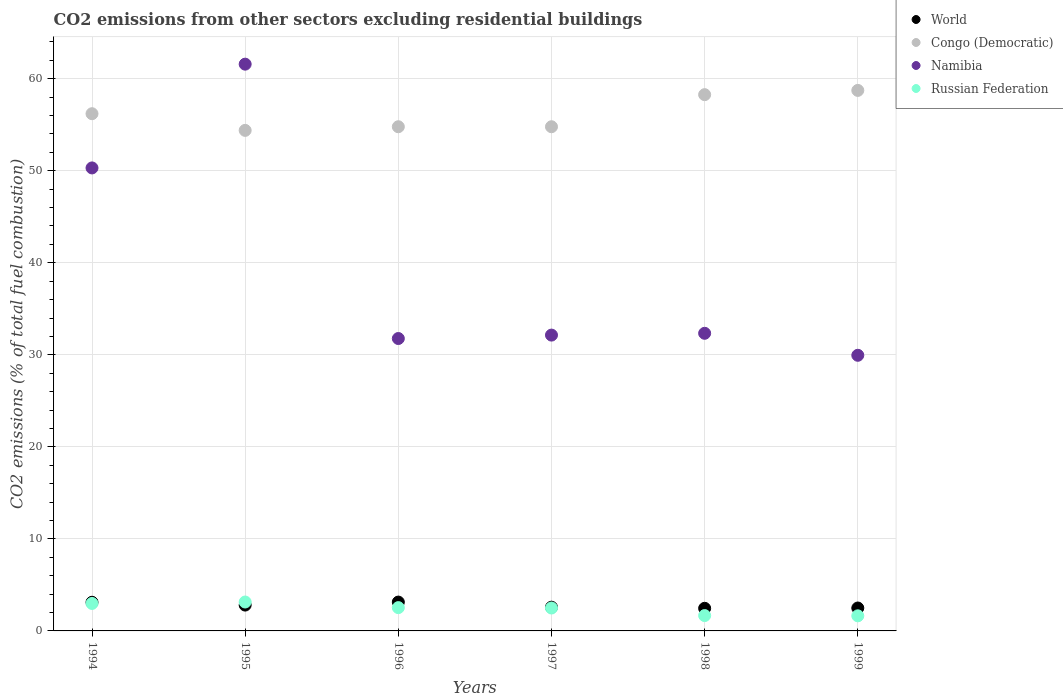How many different coloured dotlines are there?
Keep it short and to the point. 4. What is the total CO2 emitted in World in 1999?
Provide a short and direct response. 2.49. Across all years, what is the maximum total CO2 emitted in Namibia?
Ensure brevity in your answer.  61.58. Across all years, what is the minimum total CO2 emitted in World?
Your answer should be very brief. 2.46. What is the total total CO2 emitted in Congo (Democratic) in the graph?
Keep it short and to the point. 337.15. What is the difference between the total CO2 emitted in Congo (Democratic) in 1994 and that in 1998?
Keep it short and to the point. -2.07. What is the difference between the total CO2 emitted in Russian Federation in 1994 and the total CO2 emitted in World in 1995?
Your answer should be compact. 0.18. What is the average total CO2 emitted in Congo (Democratic) per year?
Offer a very short reply. 56.19. In the year 1996, what is the difference between the total CO2 emitted in World and total CO2 emitted in Namibia?
Your response must be concise. -28.64. What is the ratio of the total CO2 emitted in Congo (Democratic) in 1994 to that in 1997?
Offer a terse response. 1.03. What is the difference between the highest and the second highest total CO2 emitted in Russian Federation?
Provide a short and direct response. 0.16. What is the difference between the highest and the lowest total CO2 emitted in World?
Your response must be concise. 0.68. Is it the case that in every year, the sum of the total CO2 emitted in Congo (Democratic) and total CO2 emitted in Russian Federation  is greater than the total CO2 emitted in Namibia?
Offer a very short reply. No. Does the total CO2 emitted in World monotonically increase over the years?
Ensure brevity in your answer.  No. Is the total CO2 emitted in World strictly greater than the total CO2 emitted in Congo (Democratic) over the years?
Your answer should be compact. No. Is the total CO2 emitted in Namibia strictly less than the total CO2 emitted in Russian Federation over the years?
Offer a terse response. No. How many dotlines are there?
Keep it short and to the point. 4. How many years are there in the graph?
Your response must be concise. 6. What is the difference between two consecutive major ticks on the Y-axis?
Your answer should be compact. 10. Are the values on the major ticks of Y-axis written in scientific E-notation?
Make the answer very short. No. Does the graph contain any zero values?
Make the answer very short. No. Does the graph contain grids?
Offer a very short reply. Yes. How many legend labels are there?
Offer a terse response. 4. How are the legend labels stacked?
Offer a terse response. Vertical. What is the title of the graph?
Ensure brevity in your answer.  CO2 emissions from other sectors excluding residential buildings. Does "Latin America(all income levels)" appear as one of the legend labels in the graph?
Your response must be concise. No. What is the label or title of the X-axis?
Keep it short and to the point. Years. What is the label or title of the Y-axis?
Offer a very short reply. CO2 emissions (% of total fuel combustion). What is the CO2 emissions (% of total fuel combustion) of World in 1994?
Make the answer very short. 3.11. What is the CO2 emissions (% of total fuel combustion) in Congo (Democratic) in 1994?
Offer a terse response. 56.2. What is the CO2 emissions (% of total fuel combustion) of Namibia in 1994?
Provide a succinct answer. 50.31. What is the CO2 emissions (% of total fuel combustion) in Russian Federation in 1994?
Make the answer very short. 2.99. What is the CO2 emissions (% of total fuel combustion) of World in 1995?
Provide a short and direct response. 2.81. What is the CO2 emissions (% of total fuel combustion) in Congo (Democratic) in 1995?
Keep it short and to the point. 54.39. What is the CO2 emissions (% of total fuel combustion) in Namibia in 1995?
Provide a short and direct response. 61.58. What is the CO2 emissions (% of total fuel combustion) of Russian Federation in 1995?
Make the answer very short. 3.14. What is the CO2 emissions (% of total fuel combustion) in World in 1996?
Provide a short and direct response. 3.13. What is the CO2 emissions (% of total fuel combustion) in Congo (Democratic) in 1996?
Provide a succinct answer. 54.78. What is the CO2 emissions (% of total fuel combustion) in Namibia in 1996?
Ensure brevity in your answer.  31.77. What is the CO2 emissions (% of total fuel combustion) of Russian Federation in 1996?
Ensure brevity in your answer.  2.53. What is the CO2 emissions (% of total fuel combustion) of World in 1997?
Ensure brevity in your answer.  2.58. What is the CO2 emissions (% of total fuel combustion) of Congo (Democratic) in 1997?
Your answer should be compact. 54.78. What is the CO2 emissions (% of total fuel combustion) in Namibia in 1997?
Ensure brevity in your answer.  32.14. What is the CO2 emissions (% of total fuel combustion) in Russian Federation in 1997?
Your response must be concise. 2.49. What is the CO2 emissions (% of total fuel combustion) of World in 1998?
Ensure brevity in your answer.  2.46. What is the CO2 emissions (% of total fuel combustion) in Congo (Democratic) in 1998?
Make the answer very short. 58.27. What is the CO2 emissions (% of total fuel combustion) of Namibia in 1998?
Ensure brevity in your answer.  32.34. What is the CO2 emissions (% of total fuel combustion) in Russian Federation in 1998?
Keep it short and to the point. 1.67. What is the CO2 emissions (% of total fuel combustion) of World in 1999?
Your response must be concise. 2.49. What is the CO2 emissions (% of total fuel combustion) in Congo (Democratic) in 1999?
Offer a very short reply. 58.73. What is the CO2 emissions (% of total fuel combustion) of Namibia in 1999?
Your answer should be very brief. 29.95. What is the CO2 emissions (% of total fuel combustion) in Russian Federation in 1999?
Provide a short and direct response. 1.64. Across all years, what is the maximum CO2 emissions (% of total fuel combustion) of World?
Your answer should be compact. 3.13. Across all years, what is the maximum CO2 emissions (% of total fuel combustion) of Congo (Democratic)?
Your answer should be very brief. 58.73. Across all years, what is the maximum CO2 emissions (% of total fuel combustion) of Namibia?
Give a very brief answer. 61.58. Across all years, what is the maximum CO2 emissions (% of total fuel combustion) in Russian Federation?
Your response must be concise. 3.14. Across all years, what is the minimum CO2 emissions (% of total fuel combustion) in World?
Your response must be concise. 2.46. Across all years, what is the minimum CO2 emissions (% of total fuel combustion) in Congo (Democratic)?
Provide a short and direct response. 54.39. Across all years, what is the minimum CO2 emissions (% of total fuel combustion) in Namibia?
Provide a short and direct response. 29.95. Across all years, what is the minimum CO2 emissions (% of total fuel combustion) in Russian Federation?
Your answer should be very brief. 1.64. What is the total CO2 emissions (% of total fuel combustion) in World in the graph?
Make the answer very short. 16.58. What is the total CO2 emissions (% of total fuel combustion) of Congo (Democratic) in the graph?
Keep it short and to the point. 337.15. What is the total CO2 emissions (% of total fuel combustion) of Namibia in the graph?
Keep it short and to the point. 238.09. What is the total CO2 emissions (% of total fuel combustion) of Russian Federation in the graph?
Offer a terse response. 14.46. What is the difference between the CO2 emissions (% of total fuel combustion) in World in 1994 and that in 1995?
Make the answer very short. 0.3. What is the difference between the CO2 emissions (% of total fuel combustion) of Congo (Democratic) in 1994 and that in 1995?
Provide a short and direct response. 1.81. What is the difference between the CO2 emissions (% of total fuel combustion) of Namibia in 1994 and that in 1995?
Provide a succinct answer. -11.28. What is the difference between the CO2 emissions (% of total fuel combustion) in Russian Federation in 1994 and that in 1995?
Give a very brief answer. -0.16. What is the difference between the CO2 emissions (% of total fuel combustion) in World in 1994 and that in 1996?
Provide a short and direct response. -0.02. What is the difference between the CO2 emissions (% of total fuel combustion) in Congo (Democratic) in 1994 and that in 1996?
Offer a very short reply. 1.42. What is the difference between the CO2 emissions (% of total fuel combustion) of Namibia in 1994 and that in 1996?
Your answer should be compact. 18.54. What is the difference between the CO2 emissions (% of total fuel combustion) of Russian Federation in 1994 and that in 1996?
Give a very brief answer. 0.45. What is the difference between the CO2 emissions (% of total fuel combustion) in World in 1994 and that in 1997?
Offer a very short reply. 0.53. What is the difference between the CO2 emissions (% of total fuel combustion) in Congo (Democratic) in 1994 and that in 1997?
Keep it short and to the point. 1.42. What is the difference between the CO2 emissions (% of total fuel combustion) of Namibia in 1994 and that in 1997?
Your answer should be very brief. 18.16. What is the difference between the CO2 emissions (% of total fuel combustion) in Russian Federation in 1994 and that in 1997?
Offer a terse response. 0.5. What is the difference between the CO2 emissions (% of total fuel combustion) of World in 1994 and that in 1998?
Your response must be concise. 0.66. What is the difference between the CO2 emissions (% of total fuel combustion) of Congo (Democratic) in 1994 and that in 1998?
Ensure brevity in your answer.  -2.07. What is the difference between the CO2 emissions (% of total fuel combustion) of Namibia in 1994 and that in 1998?
Your answer should be compact. 17.97. What is the difference between the CO2 emissions (% of total fuel combustion) of Russian Federation in 1994 and that in 1998?
Make the answer very short. 1.32. What is the difference between the CO2 emissions (% of total fuel combustion) in World in 1994 and that in 1999?
Ensure brevity in your answer.  0.62. What is the difference between the CO2 emissions (% of total fuel combustion) in Congo (Democratic) in 1994 and that in 1999?
Give a very brief answer. -2.53. What is the difference between the CO2 emissions (% of total fuel combustion) in Namibia in 1994 and that in 1999?
Ensure brevity in your answer.  20.36. What is the difference between the CO2 emissions (% of total fuel combustion) in Russian Federation in 1994 and that in 1999?
Keep it short and to the point. 1.34. What is the difference between the CO2 emissions (% of total fuel combustion) in World in 1995 and that in 1996?
Your answer should be very brief. -0.33. What is the difference between the CO2 emissions (% of total fuel combustion) in Congo (Democratic) in 1995 and that in 1996?
Keep it short and to the point. -0.4. What is the difference between the CO2 emissions (% of total fuel combustion) in Namibia in 1995 and that in 1996?
Your response must be concise. 29.81. What is the difference between the CO2 emissions (% of total fuel combustion) of Russian Federation in 1995 and that in 1996?
Ensure brevity in your answer.  0.61. What is the difference between the CO2 emissions (% of total fuel combustion) in World in 1995 and that in 1997?
Your response must be concise. 0.23. What is the difference between the CO2 emissions (% of total fuel combustion) of Congo (Democratic) in 1995 and that in 1997?
Provide a short and direct response. -0.4. What is the difference between the CO2 emissions (% of total fuel combustion) in Namibia in 1995 and that in 1997?
Your answer should be very brief. 29.44. What is the difference between the CO2 emissions (% of total fuel combustion) in Russian Federation in 1995 and that in 1997?
Offer a terse response. 0.65. What is the difference between the CO2 emissions (% of total fuel combustion) of World in 1995 and that in 1998?
Keep it short and to the point. 0.35. What is the difference between the CO2 emissions (% of total fuel combustion) of Congo (Democratic) in 1995 and that in 1998?
Your response must be concise. -3.88. What is the difference between the CO2 emissions (% of total fuel combustion) in Namibia in 1995 and that in 1998?
Ensure brevity in your answer.  29.24. What is the difference between the CO2 emissions (% of total fuel combustion) in Russian Federation in 1995 and that in 1998?
Your answer should be very brief. 1.47. What is the difference between the CO2 emissions (% of total fuel combustion) in World in 1995 and that in 1999?
Provide a short and direct response. 0.32. What is the difference between the CO2 emissions (% of total fuel combustion) of Congo (Democratic) in 1995 and that in 1999?
Offer a terse response. -4.34. What is the difference between the CO2 emissions (% of total fuel combustion) of Namibia in 1995 and that in 1999?
Ensure brevity in your answer.  31.63. What is the difference between the CO2 emissions (% of total fuel combustion) of Russian Federation in 1995 and that in 1999?
Your answer should be compact. 1.5. What is the difference between the CO2 emissions (% of total fuel combustion) in World in 1996 and that in 1997?
Give a very brief answer. 0.56. What is the difference between the CO2 emissions (% of total fuel combustion) of Namibia in 1996 and that in 1997?
Your answer should be compact. -0.37. What is the difference between the CO2 emissions (% of total fuel combustion) of Russian Federation in 1996 and that in 1997?
Keep it short and to the point. 0.04. What is the difference between the CO2 emissions (% of total fuel combustion) of World in 1996 and that in 1998?
Offer a very short reply. 0.68. What is the difference between the CO2 emissions (% of total fuel combustion) in Congo (Democratic) in 1996 and that in 1998?
Provide a short and direct response. -3.49. What is the difference between the CO2 emissions (% of total fuel combustion) of Namibia in 1996 and that in 1998?
Your answer should be very brief. -0.57. What is the difference between the CO2 emissions (% of total fuel combustion) in Russian Federation in 1996 and that in 1998?
Offer a terse response. 0.86. What is the difference between the CO2 emissions (% of total fuel combustion) of World in 1996 and that in 1999?
Your response must be concise. 0.64. What is the difference between the CO2 emissions (% of total fuel combustion) in Congo (Democratic) in 1996 and that in 1999?
Keep it short and to the point. -3.95. What is the difference between the CO2 emissions (% of total fuel combustion) of Namibia in 1996 and that in 1999?
Give a very brief answer. 1.82. What is the difference between the CO2 emissions (% of total fuel combustion) of Russian Federation in 1996 and that in 1999?
Provide a short and direct response. 0.89. What is the difference between the CO2 emissions (% of total fuel combustion) of World in 1997 and that in 1998?
Keep it short and to the point. 0.12. What is the difference between the CO2 emissions (% of total fuel combustion) of Congo (Democratic) in 1997 and that in 1998?
Offer a terse response. -3.49. What is the difference between the CO2 emissions (% of total fuel combustion) in Namibia in 1997 and that in 1998?
Your answer should be compact. -0.2. What is the difference between the CO2 emissions (% of total fuel combustion) of Russian Federation in 1997 and that in 1998?
Give a very brief answer. 0.82. What is the difference between the CO2 emissions (% of total fuel combustion) of World in 1997 and that in 1999?
Ensure brevity in your answer.  0.09. What is the difference between the CO2 emissions (% of total fuel combustion) of Congo (Democratic) in 1997 and that in 1999?
Give a very brief answer. -3.95. What is the difference between the CO2 emissions (% of total fuel combustion) of Namibia in 1997 and that in 1999?
Provide a short and direct response. 2.19. What is the difference between the CO2 emissions (% of total fuel combustion) in Russian Federation in 1997 and that in 1999?
Your answer should be compact. 0.85. What is the difference between the CO2 emissions (% of total fuel combustion) in World in 1998 and that in 1999?
Provide a short and direct response. -0.03. What is the difference between the CO2 emissions (% of total fuel combustion) in Congo (Democratic) in 1998 and that in 1999?
Provide a succinct answer. -0.46. What is the difference between the CO2 emissions (% of total fuel combustion) of Namibia in 1998 and that in 1999?
Offer a terse response. 2.39. What is the difference between the CO2 emissions (% of total fuel combustion) in Russian Federation in 1998 and that in 1999?
Make the answer very short. 0.03. What is the difference between the CO2 emissions (% of total fuel combustion) in World in 1994 and the CO2 emissions (% of total fuel combustion) in Congo (Democratic) in 1995?
Keep it short and to the point. -51.27. What is the difference between the CO2 emissions (% of total fuel combustion) in World in 1994 and the CO2 emissions (% of total fuel combustion) in Namibia in 1995?
Your answer should be very brief. -58.47. What is the difference between the CO2 emissions (% of total fuel combustion) in World in 1994 and the CO2 emissions (% of total fuel combustion) in Russian Federation in 1995?
Make the answer very short. -0.03. What is the difference between the CO2 emissions (% of total fuel combustion) of Congo (Democratic) in 1994 and the CO2 emissions (% of total fuel combustion) of Namibia in 1995?
Make the answer very short. -5.38. What is the difference between the CO2 emissions (% of total fuel combustion) of Congo (Democratic) in 1994 and the CO2 emissions (% of total fuel combustion) of Russian Federation in 1995?
Your answer should be compact. 53.06. What is the difference between the CO2 emissions (% of total fuel combustion) in Namibia in 1994 and the CO2 emissions (% of total fuel combustion) in Russian Federation in 1995?
Give a very brief answer. 47.17. What is the difference between the CO2 emissions (% of total fuel combustion) of World in 1994 and the CO2 emissions (% of total fuel combustion) of Congo (Democratic) in 1996?
Your answer should be very brief. -51.67. What is the difference between the CO2 emissions (% of total fuel combustion) of World in 1994 and the CO2 emissions (% of total fuel combustion) of Namibia in 1996?
Make the answer very short. -28.66. What is the difference between the CO2 emissions (% of total fuel combustion) of World in 1994 and the CO2 emissions (% of total fuel combustion) of Russian Federation in 1996?
Offer a very short reply. 0.58. What is the difference between the CO2 emissions (% of total fuel combustion) in Congo (Democratic) in 1994 and the CO2 emissions (% of total fuel combustion) in Namibia in 1996?
Provide a short and direct response. 24.43. What is the difference between the CO2 emissions (% of total fuel combustion) in Congo (Democratic) in 1994 and the CO2 emissions (% of total fuel combustion) in Russian Federation in 1996?
Give a very brief answer. 53.67. What is the difference between the CO2 emissions (% of total fuel combustion) of Namibia in 1994 and the CO2 emissions (% of total fuel combustion) of Russian Federation in 1996?
Provide a short and direct response. 47.78. What is the difference between the CO2 emissions (% of total fuel combustion) in World in 1994 and the CO2 emissions (% of total fuel combustion) in Congo (Democratic) in 1997?
Offer a very short reply. -51.67. What is the difference between the CO2 emissions (% of total fuel combustion) of World in 1994 and the CO2 emissions (% of total fuel combustion) of Namibia in 1997?
Offer a terse response. -29.03. What is the difference between the CO2 emissions (% of total fuel combustion) of World in 1994 and the CO2 emissions (% of total fuel combustion) of Russian Federation in 1997?
Provide a succinct answer. 0.62. What is the difference between the CO2 emissions (% of total fuel combustion) of Congo (Democratic) in 1994 and the CO2 emissions (% of total fuel combustion) of Namibia in 1997?
Your answer should be very brief. 24.06. What is the difference between the CO2 emissions (% of total fuel combustion) in Congo (Democratic) in 1994 and the CO2 emissions (% of total fuel combustion) in Russian Federation in 1997?
Offer a terse response. 53.71. What is the difference between the CO2 emissions (% of total fuel combustion) of Namibia in 1994 and the CO2 emissions (% of total fuel combustion) of Russian Federation in 1997?
Your answer should be compact. 47.82. What is the difference between the CO2 emissions (% of total fuel combustion) in World in 1994 and the CO2 emissions (% of total fuel combustion) in Congo (Democratic) in 1998?
Give a very brief answer. -55.16. What is the difference between the CO2 emissions (% of total fuel combustion) of World in 1994 and the CO2 emissions (% of total fuel combustion) of Namibia in 1998?
Offer a terse response. -29.23. What is the difference between the CO2 emissions (% of total fuel combustion) of World in 1994 and the CO2 emissions (% of total fuel combustion) of Russian Federation in 1998?
Your response must be concise. 1.44. What is the difference between the CO2 emissions (% of total fuel combustion) in Congo (Democratic) in 1994 and the CO2 emissions (% of total fuel combustion) in Namibia in 1998?
Offer a terse response. 23.86. What is the difference between the CO2 emissions (% of total fuel combustion) in Congo (Democratic) in 1994 and the CO2 emissions (% of total fuel combustion) in Russian Federation in 1998?
Offer a terse response. 54.53. What is the difference between the CO2 emissions (% of total fuel combustion) in Namibia in 1994 and the CO2 emissions (% of total fuel combustion) in Russian Federation in 1998?
Offer a terse response. 48.64. What is the difference between the CO2 emissions (% of total fuel combustion) of World in 1994 and the CO2 emissions (% of total fuel combustion) of Congo (Democratic) in 1999?
Provide a short and direct response. -55.62. What is the difference between the CO2 emissions (% of total fuel combustion) of World in 1994 and the CO2 emissions (% of total fuel combustion) of Namibia in 1999?
Provide a short and direct response. -26.84. What is the difference between the CO2 emissions (% of total fuel combustion) in World in 1994 and the CO2 emissions (% of total fuel combustion) in Russian Federation in 1999?
Offer a very short reply. 1.47. What is the difference between the CO2 emissions (% of total fuel combustion) in Congo (Democratic) in 1994 and the CO2 emissions (% of total fuel combustion) in Namibia in 1999?
Give a very brief answer. 26.25. What is the difference between the CO2 emissions (% of total fuel combustion) in Congo (Democratic) in 1994 and the CO2 emissions (% of total fuel combustion) in Russian Federation in 1999?
Your response must be concise. 54.56. What is the difference between the CO2 emissions (% of total fuel combustion) in Namibia in 1994 and the CO2 emissions (% of total fuel combustion) in Russian Federation in 1999?
Provide a short and direct response. 48.67. What is the difference between the CO2 emissions (% of total fuel combustion) in World in 1995 and the CO2 emissions (% of total fuel combustion) in Congo (Democratic) in 1996?
Provide a succinct answer. -51.97. What is the difference between the CO2 emissions (% of total fuel combustion) of World in 1995 and the CO2 emissions (% of total fuel combustion) of Namibia in 1996?
Your answer should be very brief. -28.96. What is the difference between the CO2 emissions (% of total fuel combustion) of World in 1995 and the CO2 emissions (% of total fuel combustion) of Russian Federation in 1996?
Ensure brevity in your answer.  0.28. What is the difference between the CO2 emissions (% of total fuel combustion) in Congo (Democratic) in 1995 and the CO2 emissions (% of total fuel combustion) in Namibia in 1996?
Your response must be concise. 22.62. What is the difference between the CO2 emissions (% of total fuel combustion) of Congo (Democratic) in 1995 and the CO2 emissions (% of total fuel combustion) of Russian Federation in 1996?
Your answer should be very brief. 51.85. What is the difference between the CO2 emissions (% of total fuel combustion) in Namibia in 1995 and the CO2 emissions (% of total fuel combustion) in Russian Federation in 1996?
Your response must be concise. 59.05. What is the difference between the CO2 emissions (% of total fuel combustion) in World in 1995 and the CO2 emissions (% of total fuel combustion) in Congo (Democratic) in 1997?
Offer a very short reply. -51.97. What is the difference between the CO2 emissions (% of total fuel combustion) of World in 1995 and the CO2 emissions (% of total fuel combustion) of Namibia in 1997?
Give a very brief answer. -29.34. What is the difference between the CO2 emissions (% of total fuel combustion) of World in 1995 and the CO2 emissions (% of total fuel combustion) of Russian Federation in 1997?
Provide a short and direct response. 0.32. What is the difference between the CO2 emissions (% of total fuel combustion) of Congo (Democratic) in 1995 and the CO2 emissions (% of total fuel combustion) of Namibia in 1997?
Offer a very short reply. 22.24. What is the difference between the CO2 emissions (% of total fuel combustion) in Congo (Democratic) in 1995 and the CO2 emissions (% of total fuel combustion) in Russian Federation in 1997?
Your answer should be very brief. 51.9. What is the difference between the CO2 emissions (% of total fuel combustion) of Namibia in 1995 and the CO2 emissions (% of total fuel combustion) of Russian Federation in 1997?
Offer a terse response. 59.09. What is the difference between the CO2 emissions (% of total fuel combustion) of World in 1995 and the CO2 emissions (% of total fuel combustion) of Congo (Democratic) in 1998?
Ensure brevity in your answer.  -55.46. What is the difference between the CO2 emissions (% of total fuel combustion) in World in 1995 and the CO2 emissions (% of total fuel combustion) in Namibia in 1998?
Your response must be concise. -29.53. What is the difference between the CO2 emissions (% of total fuel combustion) of World in 1995 and the CO2 emissions (% of total fuel combustion) of Russian Federation in 1998?
Offer a very short reply. 1.14. What is the difference between the CO2 emissions (% of total fuel combustion) of Congo (Democratic) in 1995 and the CO2 emissions (% of total fuel combustion) of Namibia in 1998?
Keep it short and to the point. 22.05. What is the difference between the CO2 emissions (% of total fuel combustion) of Congo (Democratic) in 1995 and the CO2 emissions (% of total fuel combustion) of Russian Federation in 1998?
Your answer should be compact. 52.72. What is the difference between the CO2 emissions (% of total fuel combustion) of Namibia in 1995 and the CO2 emissions (% of total fuel combustion) of Russian Federation in 1998?
Make the answer very short. 59.91. What is the difference between the CO2 emissions (% of total fuel combustion) in World in 1995 and the CO2 emissions (% of total fuel combustion) in Congo (Democratic) in 1999?
Your response must be concise. -55.92. What is the difference between the CO2 emissions (% of total fuel combustion) of World in 1995 and the CO2 emissions (% of total fuel combustion) of Namibia in 1999?
Ensure brevity in your answer.  -27.14. What is the difference between the CO2 emissions (% of total fuel combustion) of World in 1995 and the CO2 emissions (% of total fuel combustion) of Russian Federation in 1999?
Offer a terse response. 1.17. What is the difference between the CO2 emissions (% of total fuel combustion) of Congo (Democratic) in 1995 and the CO2 emissions (% of total fuel combustion) of Namibia in 1999?
Provide a short and direct response. 24.44. What is the difference between the CO2 emissions (% of total fuel combustion) in Congo (Democratic) in 1995 and the CO2 emissions (% of total fuel combustion) in Russian Federation in 1999?
Provide a succinct answer. 52.74. What is the difference between the CO2 emissions (% of total fuel combustion) in Namibia in 1995 and the CO2 emissions (% of total fuel combustion) in Russian Federation in 1999?
Give a very brief answer. 59.94. What is the difference between the CO2 emissions (% of total fuel combustion) in World in 1996 and the CO2 emissions (% of total fuel combustion) in Congo (Democratic) in 1997?
Offer a terse response. -51.65. What is the difference between the CO2 emissions (% of total fuel combustion) of World in 1996 and the CO2 emissions (% of total fuel combustion) of Namibia in 1997?
Give a very brief answer. -29.01. What is the difference between the CO2 emissions (% of total fuel combustion) in World in 1996 and the CO2 emissions (% of total fuel combustion) in Russian Federation in 1997?
Your answer should be compact. 0.64. What is the difference between the CO2 emissions (% of total fuel combustion) of Congo (Democratic) in 1996 and the CO2 emissions (% of total fuel combustion) of Namibia in 1997?
Your answer should be compact. 22.64. What is the difference between the CO2 emissions (% of total fuel combustion) in Congo (Democratic) in 1996 and the CO2 emissions (% of total fuel combustion) in Russian Federation in 1997?
Offer a very short reply. 52.29. What is the difference between the CO2 emissions (% of total fuel combustion) of Namibia in 1996 and the CO2 emissions (% of total fuel combustion) of Russian Federation in 1997?
Offer a terse response. 29.28. What is the difference between the CO2 emissions (% of total fuel combustion) of World in 1996 and the CO2 emissions (% of total fuel combustion) of Congo (Democratic) in 1998?
Provide a succinct answer. -55.13. What is the difference between the CO2 emissions (% of total fuel combustion) in World in 1996 and the CO2 emissions (% of total fuel combustion) in Namibia in 1998?
Ensure brevity in your answer.  -29.2. What is the difference between the CO2 emissions (% of total fuel combustion) of World in 1996 and the CO2 emissions (% of total fuel combustion) of Russian Federation in 1998?
Your response must be concise. 1.47. What is the difference between the CO2 emissions (% of total fuel combustion) of Congo (Democratic) in 1996 and the CO2 emissions (% of total fuel combustion) of Namibia in 1998?
Give a very brief answer. 22.44. What is the difference between the CO2 emissions (% of total fuel combustion) in Congo (Democratic) in 1996 and the CO2 emissions (% of total fuel combustion) in Russian Federation in 1998?
Your answer should be compact. 53.12. What is the difference between the CO2 emissions (% of total fuel combustion) of Namibia in 1996 and the CO2 emissions (% of total fuel combustion) of Russian Federation in 1998?
Provide a succinct answer. 30.1. What is the difference between the CO2 emissions (% of total fuel combustion) in World in 1996 and the CO2 emissions (% of total fuel combustion) in Congo (Democratic) in 1999?
Offer a very short reply. -55.6. What is the difference between the CO2 emissions (% of total fuel combustion) in World in 1996 and the CO2 emissions (% of total fuel combustion) in Namibia in 1999?
Ensure brevity in your answer.  -26.82. What is the difference between the CO2 emissions (% of total fuel combustion) in World in 1996 and the CO2 emissions (% of total fuel combustion) in Russian Federation in 1999?
Your response must be concise. 1.49. What is the difference between the CO2 emissions (% of total fuel combustion) of Congo (Democratic) in 1996 and the CO2 emissions (% of total fuel combustion) of Namibia in 1999?
Your response must be concise. 24.83. What is the difference between the CO2 emissions (% of total fuel combustion) in Congo (Democratic) in 1996 and the CO2 emissions (% of total fuel combustion) in Russian Federation in 1999?
Keep it short and to the point. 53.14. What is the difference between the CO2 emissions (% of total fuel combustion) of Namibia in 1996 and the CO2 emissions (% of total fuel combustion) of Russian Federation in 1999?
Offer a terse response. 30.13. What is the difference between the CO2 emissions (% of total fuel combustion) in World in 1997 and the CO2 emissions (% of total fuel combustion) in Congo (Democratic) in 1998?
Provide a short and direct response. -55.69. What is the difference between the CO2 emissions (% of total fuel combustion) of World in 1997 and the CO2 emissions (% of total fuel combustion) of Namibia in 1998?
Make the answer very short. -29.76. What is the difference between the CO2 emissions (% of total fuel combustion) in World in 1997 and the CO2 emissions (% of total fuel combustion) in Russian Federation in 1998?
Your answer should be compact. 0.91. What is the difference between the CO2 emissions (% of total fuel combustion) in Congo (Democratic) in 1997 and the CO2 emissions (% of total fuel combustion) in Namibia in 1998?
Your answer should be very brief. 22.44. What is the difference between the CO2 emissions (% of total fuel combustion) in Congo (Democratic) in 1997 and the CO2 emissions (% of total fuel combustion) in Russian Federation in 1998?
Your answer should be very brief. 53.12. What is the difference between the CO2 emissions (% of total fuel combustion) of Namibia in 1997 and the CO2 emissions (% of total fuel combustion) of Russian Federation in 1998?
Keep it short and to the point. 30.48. What is the difference between the CO2 emissions (% of total fuel combustion) in World in 1997 and the CO2 emissions (% of total fuel combustion) in Congo (Democratic) in 1999?
Provide a short and direct response. -56.15. What is the difference between the CO2 emissions (% of total fuel combustion) in World in 1997 and the CO2 emissions (% of total fuel combustion) in Namibia in 1999?
Offer a very short reply. -27.37. What is the difference between the CO2 emissions (% of total fuel combustion) in World in 1997 and the CO2 emissions (% of total fuel combustion) in Russian Federation in 1999?
Keep it short and to the point. 0.94. What is the difference between the CO2 emissions (% of total fuel combustion) of Congo (Democratic) in 1997 and the CO2 emissions (% of total fuel combustion) of Namibia in 1999?
Provide a succinct answer. 24.83. What is the difference between the CO2 emissions (% of total fuel combustion) of Congo (Democratic) in 1997 and the CO2 emissions (% of total fuel combustion) of Russian Federation in 1999?
Your response must be concise. 53.14. What is the difference between the CO2 emissions (% of total fuel combustion) in Namibia in 1997 and the CO2 emissions (% of total fuel combustion) in Russian Federation in 1999?
Your answer should be very brief. 30.5. What is the difference between the CO2 emissions (% of total fuel combustion) of World in 1998 and the CO2 emissions (% of total fuel combustion) of Congo (Democratic) in 1999?
Make the answer very short. -56.27. What is the difference between the CO2 emissions (% of total fuel combustion) of World in 1998 and the CO2 emissions (% of total fuel combustion) of Namibia in 1999?
Your response must be concise. -27.49. What is the difference between the CO2 emissions (% of total fuel combustion) in World in 1998 and the CO2 emissions (% of total fuel combustion) in Russian Federation in 1999?
Your response must be concise. 0.82. What is the difference between the CO2 emissions (% of total fuel combustion) in Congo (Democratic) in 1998 and the CO2 emissions (% of total fuel combustion) in Namibia in 1999?
Give a very brief answer. 28.32. What is the difference between the CO2 emissions (% of total fuel combustion) in Congo (Democratic) in 1998 and the CO2 emissions (% of total fuel combustion) in Russian Federation in 1999?
Your answer should be very brief. 56.63. What is the difference between the CO2 emissions (% of total fuel combustion) in Namibia in 1998 and the CO2 emissions (% of total fuel combustion) in Russian Federation in 1999?
Keep it short and to the point. 30.7. What is the average CO2 emissions (% of total fuel combustion) in World per year?
Offer a very short reply. 2.76. What is the average CO2 emissions (% of total fuel combustion) in Congo (Democratic) per year?
Offer a very short reply. 56.19. What is the average CO2 emissions (% of total fuel combustion) in Namibia per year?
Make the answer very short. 39.68. What is the average CO2 emissions (% of total fuel combustion) in Russian Federation per year?
Your response must be concise. 2.41. In the year 1994, what is the difference between the CO2 emissions (% of total fuel combustion) in World and CO2 emissions (% of total fuel combustion) in Congo (Democratic)?
Offer a terse response. -53.09. In the year 1994, what is the difference between the CO2 emissions (% of total fuel combustion) in World and CO2 emissions (% of total fuel combustion) in Namibia?
Your response must be concise. -47.19. In the year 1994, what is the difference between the CO2 emissions (% of total fuel combustion) in World and CO2 emissions (% of total fuel combustion) in Russian Federation?
Keep it short and to the point. 0.13. In the year 1994, what is the difference between the CO2 emissions (% of total fuel combustion) in Congo (Democratic) and CO2 emissions (% of total fuel combustion) in Namibia?
Your answer should be compact. 5.89. In the year 1994, what is the difference between the CO2 emissions (% of total fuel combustion) of Congo (Democratic) and CO2 emissions (% of total fuel combustion) of Russian Federation?
Give a very brief answer. 53.21. In the year 1994, what is the difference between the CO2 emissions (% of total fuel combustion) in Namibia and CO2 emissions (% of total fuel combustion) in Russian Federation?
Provide a short and direct response. 47.32. In the year 1995, what is the difference between the CO2 emissions (% of total fuel combustion) in World and CO2 emissions (% of total fuel combustion) in Congo (Democratic)?
Keep it short and to the point. -51.58. In the year 1995, what is the difference between the CO2 emissions (% of total fuel combustion) of World and CO2 emissions (% of total fuel combustion) of Namibia?
Ensure brevity in your answer.  -58.77. In the year 1995, what is the difference between the CO2 emissions (% of total fuel combustion) in World and CO2 emissions (% of total fuel combustion) in Russian Federation?
Provide a succinct answer. -0.33. In the year 1995, what is the difference between the CO2 emissions (% of total fuel combustion) in Congo (Democratic) and CO2 emissions (% of total fuel combustion) in Namibia?
Your answer should be very brief. -7.2. In the year 1995, what is the difference between the CO2 emissions (% of total fuel combustion) of Congo (Democratic) and CO2 emissions (% of total fuel combustion) of Russian Federation?
Give a very brief answer. 51.24. In the year 1995, what is the difference between the CO2 emissions (% of total fuel combustion) of Namibia and CO2 emissions (% of total fuel combustion) of Russian Federation?
Make the answer very short. 58.44. In the year 1996, what is the difference between the CO2 emissions (% of total fuel combustion) of World and CO2 emissions (% of total fuel combustion) of Congo (Democratic)?
Make the answer very short. -51.65. In the year 1996, what is the difference between the CO2 emissions (% of total fuel combustion) of World and CO2 emissions (% of total fuel combustion) of Namibia?
Offer a terse response. -28.64. In the year 1996, what is the difference between the CO2 emissions (% of total fuel combustion) of World and CO2 emissions (% of total fuel combustion) of Russian Federation?
Provide a succinct answer. 0.6. In the year 1996, what is the difference between the CO2 emissions (% of total fuel combustion) of Congo (Democratic) and CO2 emissions (% of total fuel combustion) of Namibia?
Your answer should be very brief. 23.01. In the year 1996, what is the difference between the CO2 emissions (% of total fuel combustion) in Congo (Democratic) and CO2 emissions (% of total fuel combustion) in Russian Federation?
Keep it short and to the point. 52.25. In the year 1996, what is the difference between the CO2 emissions (% of total fuel combustion) of Namibia and CO2 emissions (% of total fuel combustion) of Russian Federation?
Your answer should be very brief. 29.24. In the year 1997, what is the difference between the CO2 emissions (% of total fuel combustion) in World and CO2 emissions (% of total fuel combustion) in Congo (Democratic)?
Keep it short and to the point. -52.2. In the year 1997, what is the difference between the CO2 emissions (% of total fuel combustion) of World and CO2 emissions (% of total fuel combustion) of Namibia?
Provide a succinct answer. -29.56. In the year 1997, what is the difference between the CO2 emissions (% of total fuel combustion) of World and CO2 emissions (% of total fuel combustion) of Russian Federation?
Offer a very short reply. 0.09. In the year 1997, what is the difference between the CO2 emissions (% of total fuel combustion) of Congo (Democratic) and CO2 emissions (% of total fuel combustion) of Namibia?
Your answer should be compact. 22.64. In the year 1997, what is the difference between the CO2 emissions (% of total fuel combustion) in Congo (Democratic) and CO2 emissions (% of total fuel combustion) in Russian Federation?
Your answer should be compact. 52.29. In the year 1997, what is the difference between the CO2 emissions (% of total fuel combustion) of Namibia and CO2 emissions (% of total fuel combustion) of Russian Federation?
Your answer should be very brief. 29.65. In the year 1998, what is the difference between the CO2 emissions (% of total fuel combustion) in World and CO2 emissions (% of total fuel combustion) in Congo (Democratic)?
Provide a short and direct response. -55.81. In the year 1998, what is the difference between the CO2 emissions (% of total fuel combustion) of World and CO2 emissions (% of total fuel combustion) of Namibia?
Your answer should be very brief. -29.88. In the year 1998, what is the difference between the CO2 emissions (% of total fuel combustion) of World and CO2 emissions (% of total fuel combustion) of Russian Federation?
Your answer should be very brief. 0.79. In the year 1998, what is the difference between the CO2 emissions (% of total fuel combustion) in Congo (Democratic) and CO2 emissions (% of total fuel combustion) in Namibia?
Your answer should be compact. 25.93. In the year 1998, what is the difference between the CO2 emissions (% of total fuel combustion) of Congo (Democratic) and CO2 emissions (% of total fuel combustion) of Russian Federation?
Your answer should be very brief. 56.6. In the year 1998, what is the difference between the CO2 emissions (% of total fuel combustion) in Namibia and CO2 emissions (% of total fuel combustion) in Russian Federation?
Ensure brevity in your answer.  30.67. In the year 1999, what is the difference between the CO2 emissions (% of total fuel combustion) in World and CO2 emissions (% of total fuel combustion) in Congo (Democratic)?
Offer a terse response. -56.24. In the year 1999, what is the difference between the CO2 emissions (% of total fuel combustion) in World and CO2 emissions (% of total fuel combustion) in Namibia?
Make the answer very short. -27.46. In the year 1999, what is the difference between the CO2 emissions (% of total fuel combustion) of World and CO2 emissions (% of total fuel combustion) of Russian Federation?
Provide a succinct answer. 0.85. In the year 1999, what is the difference between the CO2 emissions (% of total fuel combustion) in Congo (Democratic) and CO2 emissions (% of total fuel combustion) in Namibia?
Offer a very short reply. 28.78. In the year 1999, what is the difference between the CO2 emissions (% of total fuel combustion) of Congo (Democratic) and CO2 emissions (% of total fuel combustion) of Russian Federation?
Keep it short and to the point. 57.09. In the year 1999, what is the difference between the CO2 emissions (% of total fuel combustion) in Namibia and CO2 emissions (% of total fuel combustion) in Russian Federation?
Make the answer very short. 28.31. What is the ratio of the CO2 emissions (% of total fuel combustion) of World in 1994 to that in 1995?
Your answer should be very brief. 1.11. What is the ratio of the CO2 emissions (% of total fuel combustion) in Namibia in 1994 to that in 1995?
Give a very brief answer. 0.82. What is the ratio of the CO2 emissions (% of total fuel combustion) of Russian Federation in 1994 to that in 1995?
Your answer should be compact. 0.95. What is the ratio of the CO2 emissions (% of total fuel combustion) in World in 1994 to that in 1996?
Make the answer very short. 0.99. What is the ratio of the CO2 emissions (% of total fuel combustion) of Congo (Democratic) in 1994 to that in 1996?
Give a very brief answer. 1.03. What is the ratio of the CO2 emissions (% of total fuel combustion) in Namibia in 1994 to that in 1996?
Your answer should be very brief. 1.58. What is the ratio of the CO2 emissions (% of total fuel combustion) of Russian Federation in 1994 to that in 1996?
Keep it short and to the point. 1.18. What is the ratio of the CO2 emissions (% of total fuel combustion) in World in 1994 to that in 1997?
Make the answer very short. 1.21. What is the ratio of the CO2 emissions (% of total fuel combustion) of Congo (Democratic) in 1994 to that in 1997?
Offer a very short reply. 1.03. What is the ratio of the CO2 emissions (% of total fuel combustion) of Namibia in 1994 to that in 1997?
Offer a terse response. 1.57. What is the ratio of the CO2 emissions (% of total fuel combustion) in Russian Federation in 1994 to that in 1997?
Make the answer very short. 1.2. What is the ratio of the CO2 emissions (% of total fuel combustion) of World in 1994 to that in 1998?
Your response must be concise. 1.27. What is the ratio of the CO2 emissions (% of total fuel combustion) in Congo (Democratic) in 1994 to that in 1998?
Your answer should be compact. 0.96. What is the ratio of the CO2 emissions (% of total fuel combustion) in Namibia in 1994 to that in 1998?
Provide a short and direct response. 1.56. What is the ratio of the CO2 emissions (% of total fuel combustion) of Russian Federation in 1994 to that in 1998?
Your answer should be compact. 1.79. What is the ratio of the CO2 emissions (% of total fuel combustion) in World in 1994 to that in 1999?
Your response must be concise. 1.25. What is the ratio of the CO2 emissions (% of total fuel combustion) in Congo (Democratic) in 1994 to that in 1999?
Your answer should be compact. 0.96. What is the ratio of the CO2 emissions (% of total fuel combustion) in Namibia in 1994 to that in 1999?
Offer a very short reply. 1.68. What is the ratio of the CO2 emissions (% of total fuel combustion) of Russian Federation in 1994 to that in 1999?
Make the answer very short. 1.82. What is the ratio of the CO2 emissions (% of total fuel combustion) of World in 1995 to that in 1996?
Offer a terse response. 0.9. What is the ratio of the CO2 emissions (% of total fuel combustion) in Congo (Democratic) in 1995 to that in 1996?
Keep it short and to the point. 0.99. What is the ratio of the CO2 emissions (% of total fuel combustion) of Namibia in 1995 to that in 1996?
Offer a terse response. 1.94. What is the ratio of the CO2 emissions (% of total fuel combustion) of Russian Federation in 1995 to that in 1996?
Ensure brevity in your answer.  1.24. What is the ratio of the CO2 emissions (% of total fuel combustion) in World in 1995 to that in 1997?
Keep it short and to the point. 1.09. What is the ratio of the CO2 emissions (% of total fuel combustion) of Namibia in 1995 to that in 1997?
Ensure brevity in your answer.  1.92. What is the ratio of the CO2 emissions (% of total fuel combustion) of Russian Federation in 1995 to that in 1997?
Your answer should be very brief. 1.26. What is the ratio of the CO2 emissions (% of total fuel combustion) of World in 1995 to that in 1998?
Your answer should be compact. 1.14. What is the ratio of the CO2 emissions (% of total fuel combustion) of Congo (Democratic) in 1995 to that in 1998?
Offer a very short reply. 0.93. What is the ratio of the CO2 emissions (% of total fuel combustion) of Namibia in 1995 to that in 1998?
Your response must be concise. 1.9. What is the ratio of the CO2 emissions (% of total fuel combustion) in Russian Federation in 1995 to that in 1998?
Offer a very short reply. 1.88. What is the ratio of the CO2 emissions (% of total fuel combustion) in World in 1995 to that in 1999?
Your answer should be very brief. 1.13. What is the ratio of the CO2 emissions (% of total fuel combustion) in Congo (Democratic) in 1995 to that in 1999?
Your answer should be compact. 0.93. What is the ratio of the CO2 emissions (% of total fuel combustion) in Namibia in 1995 to that in 1999?
Your answer should be very brief. 2.06. What is the ratio of the CO2 emissions (% of total fuel combustion) in Russian Federation in 1995 to that in 1999?
Keep it short and to the point. 1.91. What is the ratio of the CO2 emissions (% of total fuel combustion) in World in 1996 to that in 1997?
Offer a terse response. 1.22. What is the ratio of the CO2 emissions (% of total fuel combustion) in Congo (Democratic) in 1996 to that in 1997?
Provide a succinct answer. 1. What is the ratio of the CO2 emissions (% of total fuel combustion) of Namibia in 1996 to that in 1997?
Ensure brevity in your answer.  0.99. What is the ratio of the CO2 emissions (% of total fuel combustion) in Russian Federation in 1996 to that in 1997?
Offer a terse response. 1.02. What is the ratio of the CO2 emissions (% of total fuel combustion) in World in 1996 to that in 1998?
Keep it short and to the point. 1.28. What is the ratio of the CO2 emissions (% of total fuel combustion) of Congo (Democratic) in 1996 to that in 1998?
Your response must be concise. 0.94. What is the ratio of the CO2 emissions (% of total fuel combustion) of Namibia in 1996 to that in 1998?
Offer a very short reply. 0.98. What is the ratio of the CO2 emissions (% of total fuel combustion) in Russian Federation in 1996 to that in 1998?
Provide a short and direct response. 1.52. What is the ratio of the CO2 emissions (% of total fuel combustion) in World in 1996 to that in 1999?
Your answer should be compact. 1.26. What is the ratio of the CO2 emissions (% of total fuel combustion) of Congo (Democratic) in 1996 to that in 1999?
Make the answer very short. 0.93. What is the ratio of the CO2 emissions (% of total fuel combustion) in Namibia in 1996 to that in 1999?
Keep it short and to the point. 1.06. What is the ratio of the CO2 emissions (% of total fuel combustion) of Russian Federation in 1996 to that in 1999?
Your answer should be compact. 1.54. What is the ratio of the CO2 emissions (% of total fuel combustion) in World in 1997 to that in 1998?
Make the answer very short. 1.05. What is the ratio of the CO2 emissions (% of total fuel combustion) in Congo (Democratic) in 1997 to that in 1998?
Offer a very short reply. 0.94. What is the ratio of the CO2 emissions (% of total fuel combustion) in Namibia in 1997 to that in 1998?
Ensure brevity in your answer.  0.99. What is the ratio of the CO2 emissions (% of total fuel combustion) in Russian Federation in 1997 to that in 1998?
Ensure brevity in your answer.  1.49. What is the ratio of the CO2 emissions (% of total fuel combustion) in World in 1997 to that in 1999?
Give a very brief answer. 1.04. What is the ratio of the CO2 emissions (% of total fuel combustion) in Congo (Democratic) in 1997 to that in 1999?
Give a very brief answer. 0.93. What is the ratio of the CO2 emissions (% of total fuel combustion) in Namibia in 1997 to that in 1999?
Your response must be concise. 1.07. What is the ratio of the CO2 emissions (% of total fuel combustion) in Russian Federation in 1997 to that in 1999?
Offer a terse response. 1.52. What is the ratio of the CO2 emissions (% of total fuel combustion) in World in 1998 to that in 1999?
Keep it short and to the point. 0.99. What is the ratio of the CO2 emissions (% of total fuel combustion) in Congo (Democratic) in 1998 to that in 1999?
Your answer should be very brief. 0.99. What is the ratio of the CO2 emissions (% of total fuel combustion) in Namibia in 1998 to that in 1999?
Offer a terse response. 1.08. What is the ratio of the CO2 emissions (% of total fuel combustion) in Russian Federation in 1998 to that in 1999?
Your answer should be compact. 1.02. What is the difference between the highest and the second highest CO2 emissions (% of total fuel combustion) of World?
Ensure brevity in your answer.  0.02. What is the difference between the highest and the second highest CO2 emissions (% of total fuel combustion) of Congo (Democratic)?
Give a very brief answer. 0.46. What is the difference between the highest and the second highest CO2 emissions (% of total fuel combustion) of Namibia?
Provide a short and direct response. 11.28. What is the difference between the highest and the second highest CO2 emissions (% of total fuel combustion) in Russian Federation?
Offer a very short reply. 0.16. What is the difference between the highest and the lowest CO2 emissions (% of total fuel combustion) of World?
Offer a terse response. 0.68. What is the difference between the highest and the lowest CO2 emissions (% of total fuel combustion) in Congo (Democratic)?
Your answer should be compact. 4.34. What is the difference between the highest and the lowest CO2 emissions (% of total fuel combustion) in Namibia?
Your answer should be compact. 31.63. What is the difference between the highest and the lowest CO2 emissions (% of total fuel combustion) of Russian Federation?
Offer a terse response. 1.5. 